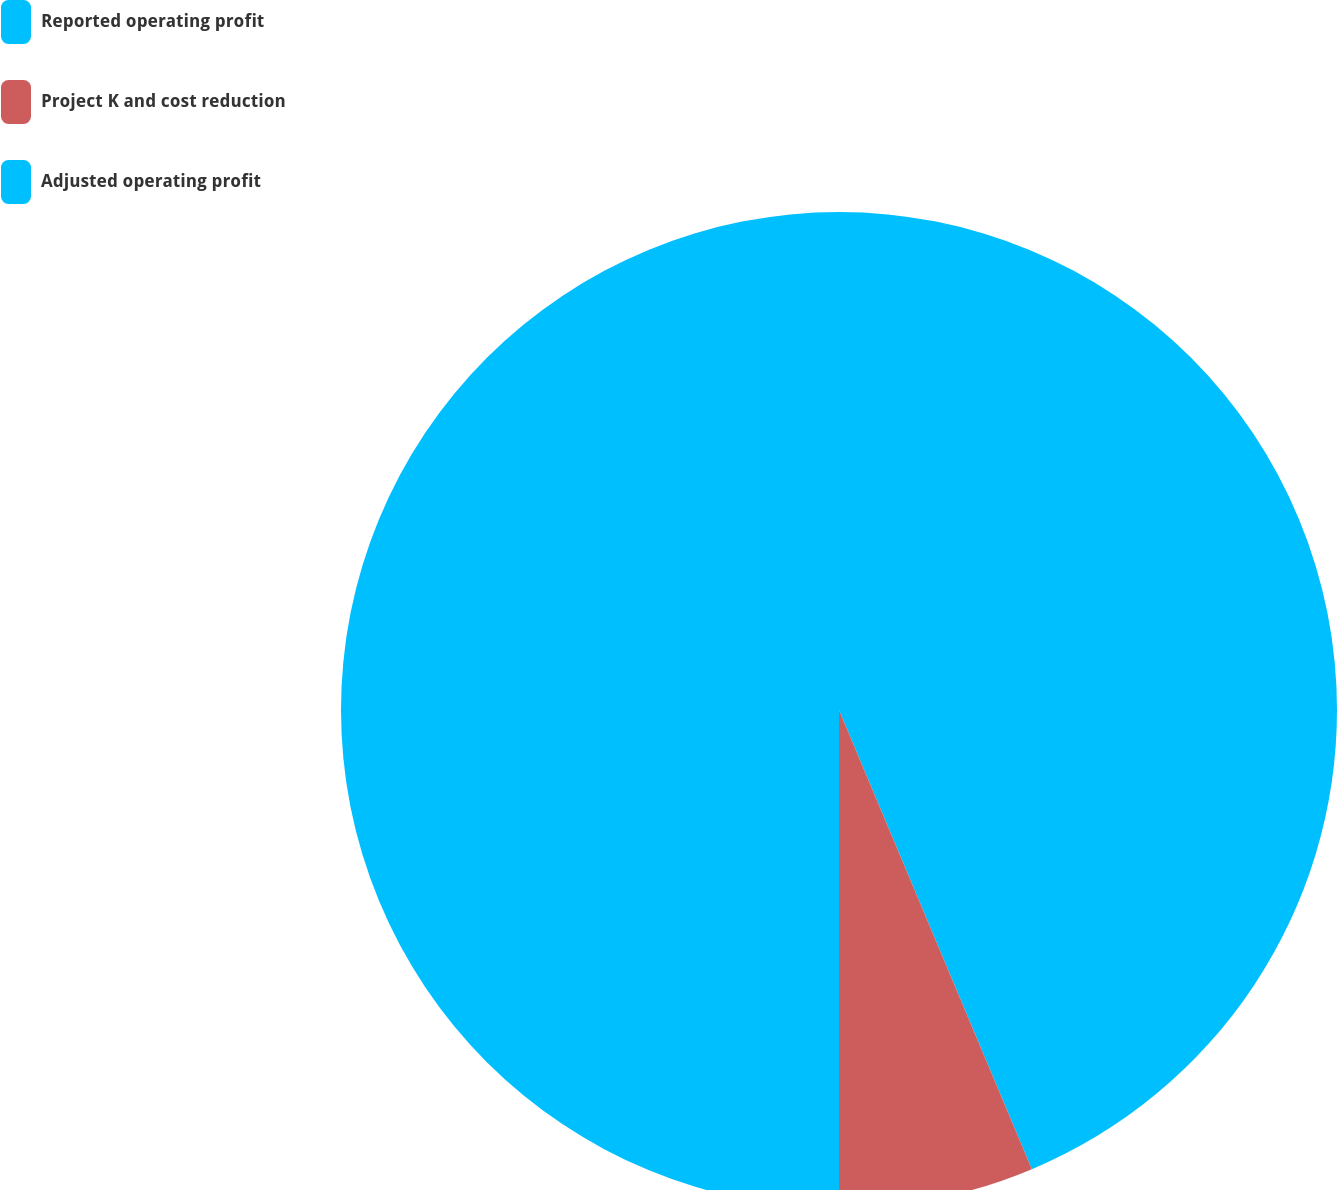Convert chart to OTSL. <chart><loc_0><loc_0><loc_500><loc_500><pie_chart><fcel>Reported operating profit<fcel>Project K and cost reduction<fcel>Adjusted operating profit<nl><fcel>43.67%<fcel>6.33%<fcel>50.0%<nl></chart> 